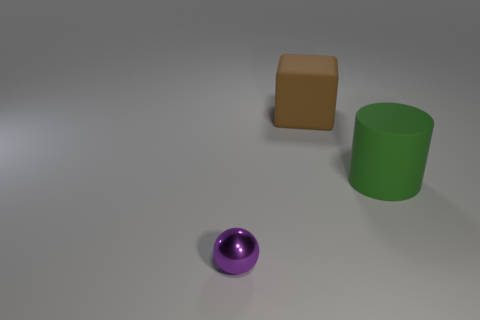Add 1 brown matte cubes. How many brown matte cubes exist? 2 Add 1 small purple balls. How many objects exist? 4 Subtract 0 brown cylinders. How many objects are left? 3 Subtract all balls. How many objects are left? 2 Subtract all cyan cubes. Subtract all cyan balls. How many cubes are left? 1 Subtract all tiny purple balls. Subtract all large yellow things. How many objects are left? 2 Add 3 big brown cubes. How many big brown cubes are left? 4 